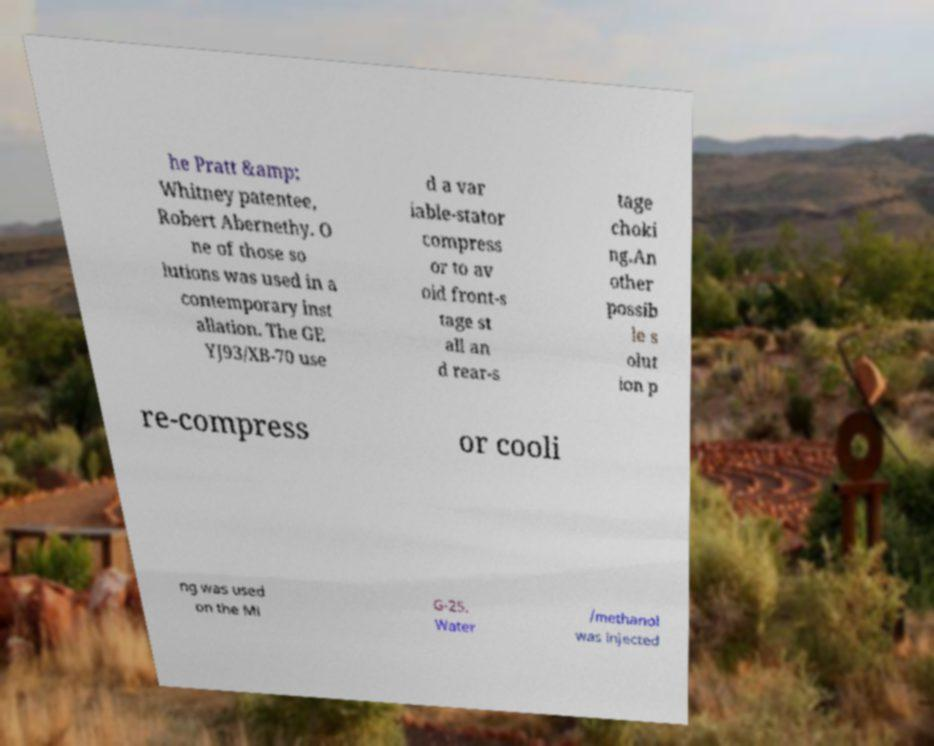There's text embedded in this image that I need extracted. Can you transcribe it verbatim? he Pratt &amp; Whitney patentee, Robert Abernethy. O ne of those so lutions was used in a contemporary inst allation. The GE YJ93/XB-70 use d a var iable-stator compress or to av oid front-s tage st all an d rear-s tage choki ng.An other possib le s olut ion p re-compress or cooli ng was used on the Mi G-25. Water /methanol was injected 